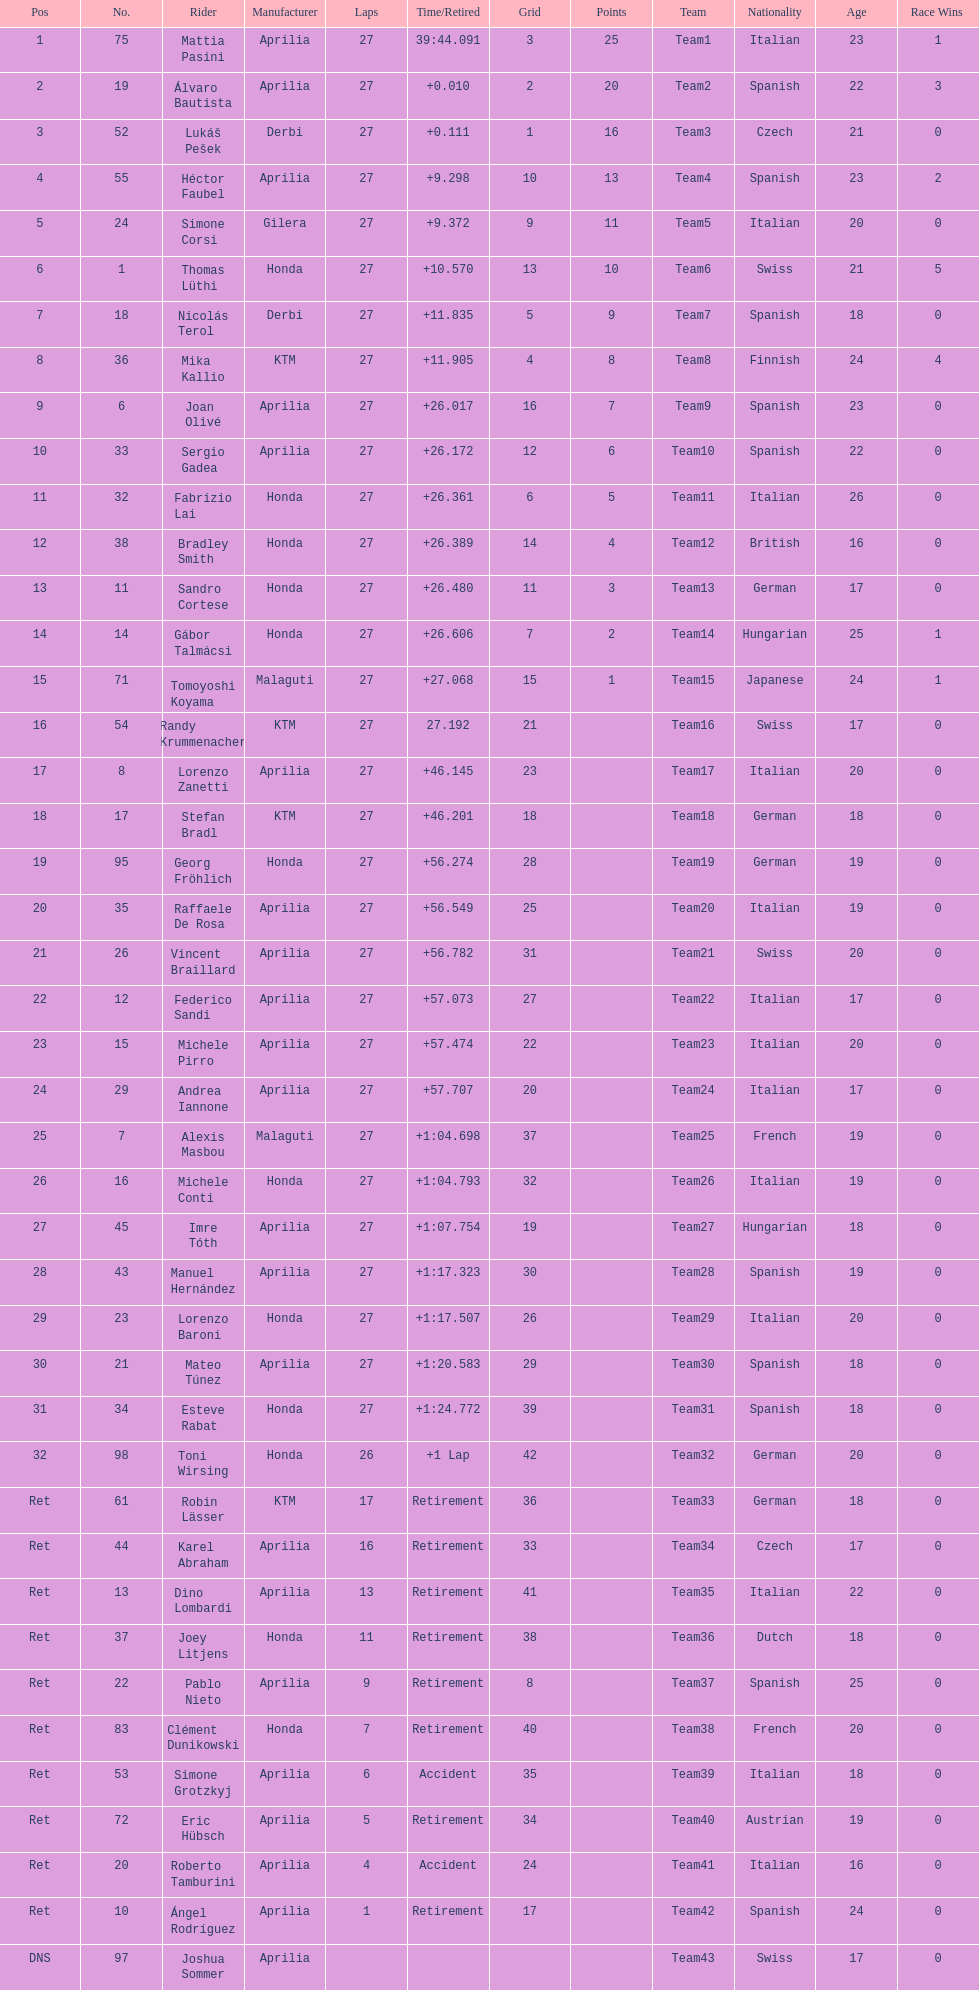Parse the table in full. {'header': ['Pos', 'No.', 'Rider', 'Manufacturer', 'Laps', 'Time/Retired', 'Grid', 'Points', 'Team', 'Nationality', 'Age', 'Race Wins\r'], 'rows': [['1', '75', 'Mattia Pasini', 'Aprilia', '27', '39:44.091', '3', '25', 'Team1', 'Italian', '23', '1\r'], ['2', '19', 'Álvaro Bautista', 'Aprilia', '27', '+0.010', '2', '20', 'Team2', 'Spanish', '22', '3\r'], ['3', '52', 'Lukáš Pešek', 'Derbi', '27', '+0.111', '1', '16', 'Team3', 'Czech', '21', '0\r'], ['4', '55', 'Héctor Faubel', 'Aprilia', '27', '+9.298', '10', '13', 'Team4', 'Spanish', '23', '2\r'], ['5', '24', 'Simone Corsi', 'Gilera', '27', '+9.372', '9', '11', 'Team5', 'Italian', '20', '0\r'], ['6', '1', 'Thomas Lüthi', 'Honda', '27', '+10.570', '13', '10', 'Team6', 'Swiss', '21', '5\r'], ['7', '18', 'Nicolás Terol', 'Derbi', '27', '+11.835', '5', '9', 'Team7', 'Spanish', '18', '0\r'], ['8', '36', 'Mika Kallio', 'KTM', '27', '+11.905', '4', '8', 'Team8', 'Finnish', '24', '4\r'], ['9', '6', 'Joan Olivé', 'Aprilia', '27', '+26.017', '16', '7', 'Team9', 'Spanish', '23', '0\r'], ['10', '33', 'Sergio Gadea', 'Aprilia', '27', '+26.172', '12', '6', 'Team10', 'Spanish', '22', '0\r'], ['11', '32', 'Fabrizio Lai', 'Honda', '27', '+26.361', '6', '5', 'Team11', 'Italian', '26', '0\r'], ['12', '38', 'Bradley Smith', 'Honda', '27', '+26.389', '14', '4', 'Team12', 'British', '16', '0\r'], ['13', '11', 'Sandro Cortese', 'Honda', '27', '+26.480', '11', '3', 'Team13', 'German', '17', '0\r'], ['14', '14', 'Gábor Talmácsi', 'Honda', '27', '+26.606', '7', '2', 'Team14', 'Hungarian', '25', '1\r'], ['15', '71', 'Tomoyoshi Koyama', 'Malaguti', '27', '+27.068', '15', '1', 'Team15', 'Japanese', '24', '1\r'], ['16', '54', 'Randy Krummenacher', 'KTM', '27', '27.192', '21', '', 'Team16', 'Swiss', '17', '0\r'], ['17', '8', 'Lorenzo Zanetti', 'Aprilia', '27', '+46.145', '23', '', 'Team17', 'Italian', '20', '0\r'], ['18', '17', 'Stefan Bradl', 'KTM', '27', '+46.201', '18', '', 'Team18', 'German', '18', '0\r'], ['19', '95', 'Georg Fröhlich', 'Honda', '27', '+56.274', '28', '', 'Team19', 'German', '19', '0\r'], ['20', '35', 'Raffaele De Rosa', 'Aprilia', '27', '+56.549', '25', '', 'Team20', 'Italian', '19', '0\r'], ['21', '26', 'Vincent Braillard', 'Aprilia', '27', '+56.782', '31', '', 'Team21', 'Swiss', '20', '0\r'], ['22', '12', 'Federico Sandi', 'Aprilia', '27', '+57.073', '27', '', 'Team22', 'Italian', '17', '0\r'], ['23', '15', 'Michele Pirro', 'Aprilia', '27', '+57.474', '22', '', 'Team23', 'Italian', '20', '0\r'], ['24', '29', 'Andrea Iannone', 'Aprilia', '27', '+57.707', '20', '', 'Team24', 'Italian', '17', '0\r'], ['25', '7', 'Alexis Masbou', 'Malaguti', '27', '+1:04.698', '37', '', 'Team25', 'French', '19', '0\r'], ['26', '16', 'Michele Conti', 'Honda', '27', '+1:04.793', '32', '', 'Team26', 'Italian', '19', '0\r'], ['27', '45', 'Imre Tóth', 'Aprilia', '27', '+1:07.754', '19', '', 'Team27', 'Hungarian', '18', '0\r'], ['28', '43', 'Manuel Hernández', 'Aprilia', '27', '+1:17.323', '30', '', 'Team28', 'Spanish', '19', '0\r'], ['29', '23', 'Lorenzo Baroni', 'Honda', '27', '+1:17.507', '26', '', 'Team29', 'Italian', '20', '0\r'], ['30', '21', 'Mateo Túnez', 'Aprilia', '27', '+1:20.583', '29', '', 'Team30', 'Spanish', '18', '0\r'], ['31', '34', 'Esteve Rabat', 'Honda', '27', '+1:24.772', '39', '', 'Team31', 'Spanish', '18', '0\r'], ['32', '98', 'Toni Wirsing', 'Honda', '26', '+1 Lap', '42', '', 'Team32', 'German', '20', '0\r'], ['Ret', '61', 'Robin Lässer', 'KTM', '17', 'Retirement', '36', '', 'Team33', 'German', '18', '0\r'], ['Ret', '44', 'Karel Abraham', 'Aprilia', '16', 'Retirement', '33', '', 'Team34', 'Czech', '17', '0\r'], ['Ret', '13', 'Dino Lombardi', 'Aprilia', '13', 'Retirement', '41', '', 'Team35', 'Italian', '22', '0\r'], ['Ret', '37', 'Joey Litjens', 'Honda', '11', 'Retirement', '38', '', 'Team36', 'Dutch', '18', '0\r'], ['Ret', '22', 'Pablo Nieto', 'Aprilia', '9', 'Retirement', '8', '', 'Team37', 'Spanish', '25', '0\r'], ['Ret', '83', 'Clément Dunikowski', 'Honda', '7', 'Retirement', '40', '', 'Team38', 'French', '20', '0\r'], ['Ret', '53', 'Simone Grotzkyj', 'Aprilia', '6', 'Accident', '35', '', 'Team39', 'Italian', '18', '0\r'], ['Ret', '72', 'Eric Hübsch', 'Aprilia', '5', 'Retirement', '34', '', 'Team40', 'Austrian', '19', '0\r'], ['Ret', '20', 'Roberto Tamburini', 'Aprilia', '4', 'Accident', '24', '', 'Team41', 'Italian', '16', '0\r'], ['Ret', '10', 'Ángel Rodríguez', 'Aprilia', '1', 'Retirement', '17', '', 'Team42', 'Spanish', '24', '0\r'], ['DNS', '97', 'Joshua Sommer', 'Aprilia', '', '', '', '', 'Team43', 'Swiss', '17', '0']]} How many german racers finished the race? 4. 